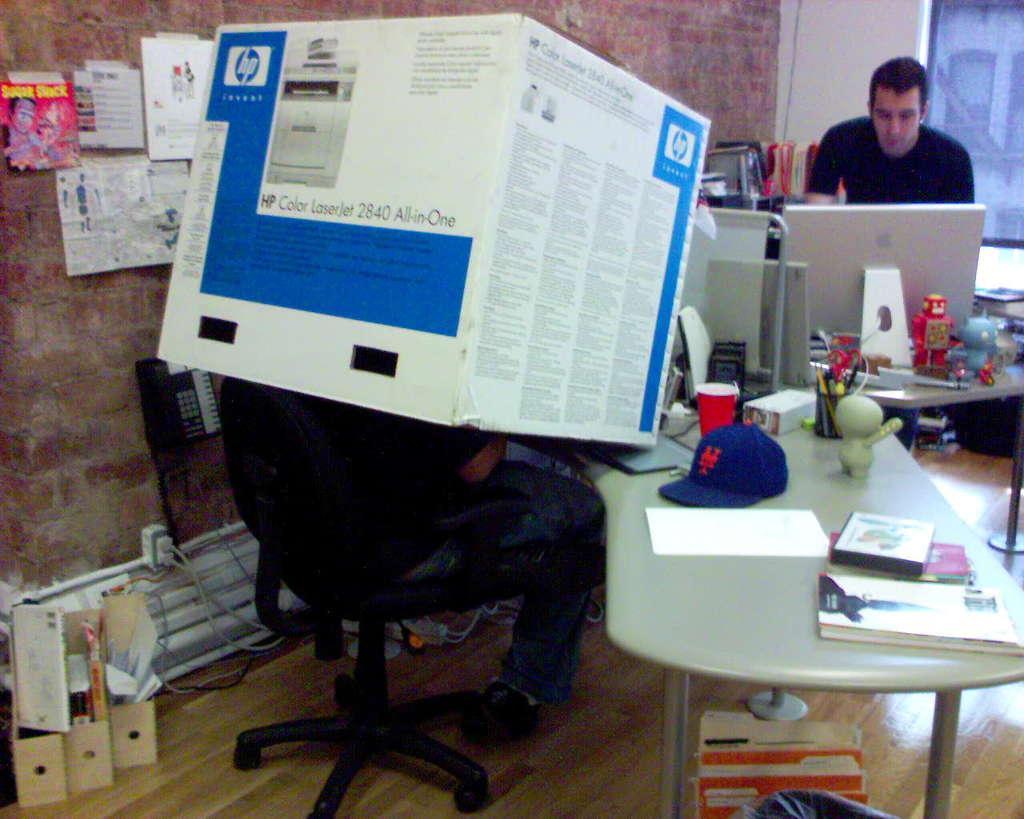Can you describe this image briefly? This is a table with a book,cap,glass,paper,pen stand and some other objects. I can see a person sitting on the chair. This is a cardboard. I can see a telephone attached to the wall. There is another person standing and working on the computer. I can see some posts attached to the wall. 